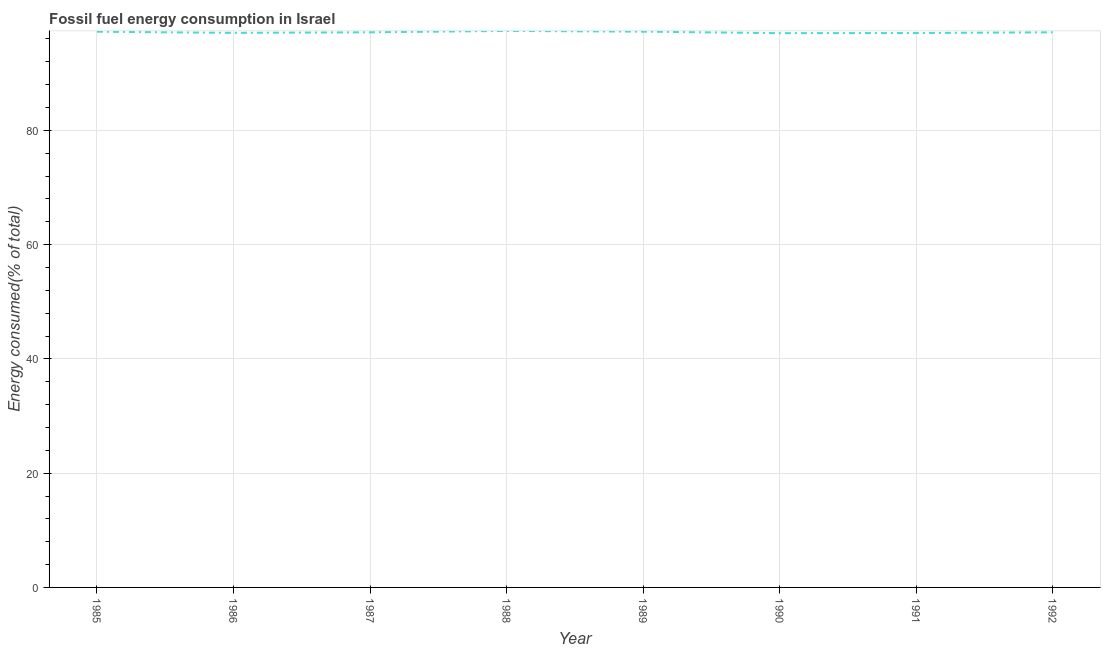What is the fossil fuel energy consumption in 1991?
Your answer should be compact. 97.03. Across all years, what is the maximum fossil fuel energy consumption?
Provide a succinct answer. 97.39. Across all years, what is the minimum fossil fuel energy consumption?
Provide a succinct answer. 97.01. What is the sum of the fossil fuel energy consumption?
Ensure brevity in your answer.  777.31. What is the difference between the fossil fuel energy consumption in 1987 and 1989?
Provide a short and direct response. -0.11. What is the average fossil fuel energy consumption per year?
Ensure brevity in your answer.  97.16. What is the median fossil fuel energy consumption?
Give a very brief answer. 97.15. In how many years, is the fossil fuel energy consumption greater than 84 %?
Provide a short and direct response. 8. What is the ratio of the fossil fuel energy consumption in 1987 to that in 1991?
Make the answer very short. 1. Is the difference between the fossil fuel energy consumption in 1988 and 1990 greater than the difference between any two years?
Offer a very short reply. Yes. What is the difference between the highest and the second highest fossil fuel energy consumption?
Offer a terse response. 0.13. Is the sum of the fossil fuel energy consumption in 1989 and 1990 greater than the maximum fossil fuel energy consumption across all years?
Ensure brevity in your answer.  Yes. What is the difference between the highest and the lowest fossil fuel energy consumption?
Make the answer very short. 0.39. How many lines are there?
Provide a short and direct response. 1. How many years are there in the graph?
Your answer should be compact. 8. Are the values on the major ticks of Y-axis written in scientific E-notation?
Offer a very short reply. No. Does the graph contain any zero values?
Make the answer very short. No. Does the graph contain grids?
Make the answer very short. Yes. What is the title of the graph?
Keep it short and to the point. Fossil fuel energy consumption in Israel. What is the label or title of the X-axis?
Keep it short and to the point. Year. What is the label or title of the Y-axis?
Give a very brief answer. Energy consumed(% of total). What is the Energy consumed(% of total) in 1985?
Make the answer very short. 97.26. What is the Energy consumed(% of total) in 1986?
Make the answer very short. 97.06. What is the Energy consumed(% of total) of 1987?
Provide a short and direct response. 97.15. What is the Energy consumed(% of total) in 1988?
Ensure brevity in your answer.  97.39. What is the Energy consumed(% of total) of 1989?
Your answer should be very brief. 97.27. What is the Energy consumed(% of total) in 1990?
Give a very brief answer. 97.01. What is the Energy consumed(% of total) of 1991?
Provide a succinct answer. 97.03. What is the Energy consumed(% of total) of 1992?
Provide a succinct answer. 97.15. What is the difference between the Energy consumed(% of total) in 1985 and 1986?
Your answer should be very brief. 0.2. What is the difference between the Energy consumed(% of total) in 1985 and 1987?
Keep it short and to the point. 0.1. What is the difference between the Energy consumed(% of total) in 1985 and 1988?
Your answer should be very brief. -0.14. What is the difference between the Energy consumed(% of total) in 1985 and 1989?
Your response must be concise. -0.01. What is the difference between the Energy consumed(% of total) in 1985 and 1990?
Make the answer very short. 0.25. What is the difference between the Energy consumed(% of total) in 1985 and 1991?
Provide a short and direct response. 0.23. What is the difference between the Energy consumed(% of total) in 1985 and 1992?
Offer a terse response. 0.1. What is the difference between the Energy consumed(% of total) in 1986 and 1987?
Make the answer very short. -0.1. What is the difference between the Energy consumed(% of total) in 1986 and 1988?
Ensure brevity in your answer.  -0.34. What is the difference between the Energy consumed(% of total) in 1986 and 1989?
Your response must be concise. -0.21. What is the difference between the Energy consumed(% of total) in 1986 and 1990?
Offer a very short reply. 0.05. What is the difference between the Energy consumed(% of total) in 1986 and 1991?
Ensure brevity in your answer.  0.03. What is the difference between the Energy consumed(% of total) in 1986 and 1992?
Provide a short and direct response. -0.1. What is the difference between the Energy consumed(% of total) in 1987 and 1988?
Your answer should be compact. -0.24. What is the difference between the Energy consumed(% of total) in 1987 and 1989?
Give a very brief answer. -0.11. What is the difference between the Energy consumed(% of total) in 1987 and 1990?
Offer a terse response. 0.15. What is the difference between the Energy consumed(% of total) in 1987 and 1991?
Give a very brief answer. 0.13. What is the difference between the Energy consumed(% of total) in 1987 and 1992?
Offer a very short reply. -0. What is the difference between the Energy consumed(% of total) in 1988 and 1989?
Your answer should be compact. 0.13. What is the difference between the Energy consumed(% of total) in 1988 and 1990?
Provide a short and direct response. 0.39. What is the difference between the Energy consumed(% of total) in 1988 and 1991?
Your answer should be compact. 0.37. What is the difference between the Energy consumed(% of total) in 1988 and 1992?
Your response must be concise. 0.24. What is the difference between the Energy consumed(% of total) in 1989 and 1990?
Give a very brief answer. 0.26. What is the difference between the Energy consumed(% of total) in 1989 and 1991?
Your answer should be very brief. 0.24. What is the difference between the Energy consumed(% of total) in 1989 and 1992?
Provide a short and direct response. 0.11. What is the difference between the Energy consumed(% of total) in 1990 and 1991?
Offer a terse response. -0.02. What is the difference between the Energy consumed(% of total) in 1990 and 1992?
Make the answer very short. -0.15. What is the difference between the Energy consumed(% of total) in 1991 and 1992?
Offer a very short reply. -0.13. What is the ratio of the Energy consumed(% of total) in 1985 to that in 1986?
Ensure brevity in your answer.  1. What is the ratio of the Energy consumed(% of total) in 1985 to that in 1987?
Your answer should be very brief. 1. What is the ratio of the Energy consumed(% of total) in 1985 to that in 1988?
Make the answer very short. 1. What is the ratio of the Energy consumed(% of total) in 1985 to that in 1990?
Offer a very short reply. 1. What is the ratio of the Energy consumed(% of total) in 1985 to that in 1991?
Offer a very short reply. 1. What is the ratio of the Energy consumed(% of total) in 1986 to that in 1987?
Provide a succinct answer. 1. What is the ratio of the Energy consumed(% of total) in 1986 to that in 1988?
Make the answer very short. 1. What is the ratio of the Energy consumed(% of total) in 1986 to that in 1990?
Make the answer very short. 1. What is the ratio of the Energy consumed(% of total) in 1986 to that in 1991?
Offer a terse response. 1. What is the ratio of the Energy consumed(% of total) in 1986 to that in 1992?
Ensure brevity in your answer.  1. What is the ratio of the Energy consumed(% of total) in 1987 to that in 1989?
Keep it short and to the point. 1. What is the ratio of the Energy consumed(% of total) in 1987 to that in 1990?
Provide a short and direct response. 1. What is the ratio of the Energy consumed(% of total) in 1987 to that in 1991?
Provide a succinct answer. 1. What is the ratio of the Energy consumed(% of total) in 1987 to that in 1992?
Provide a succinct answer. 1. What is the ratio of the Energy consumed(% of total) in 1988 to that in 1989?
Your answer should be very brief. 1. What is the ratio of the Energy consumed(% of total) in 1988 to that in 1990?
Offer a terse response. 1. What is the ratio of the Energy consumed(% of total) in 1988 to that in 1991?
Make the answer very short. 1. What is the ratio of the Energy consumed(% of total) in 1988 to that in 1992?
Your answer should be very brief. 1. What is the ratio of the Energy consumed(% of total) in 1989 to that in 1990?
Provide a short and direct response. 1. What is the ratio of the Energy consumed(% of total) in 1989 to that in 1991?
Your answer should be compact. 1. What is the ratio of the Energy consumed(% of total) in 1989 to that in 1992?
Make the answer very short. 1. What is the ratio of the Energy consumed(% of total) in 1990 to that in 1991?
Offer a terse response. 1. What is the ratio of the Energy consumed(% of total) in 1990 to that in 1992?
Provide a succinct answer. 1. 